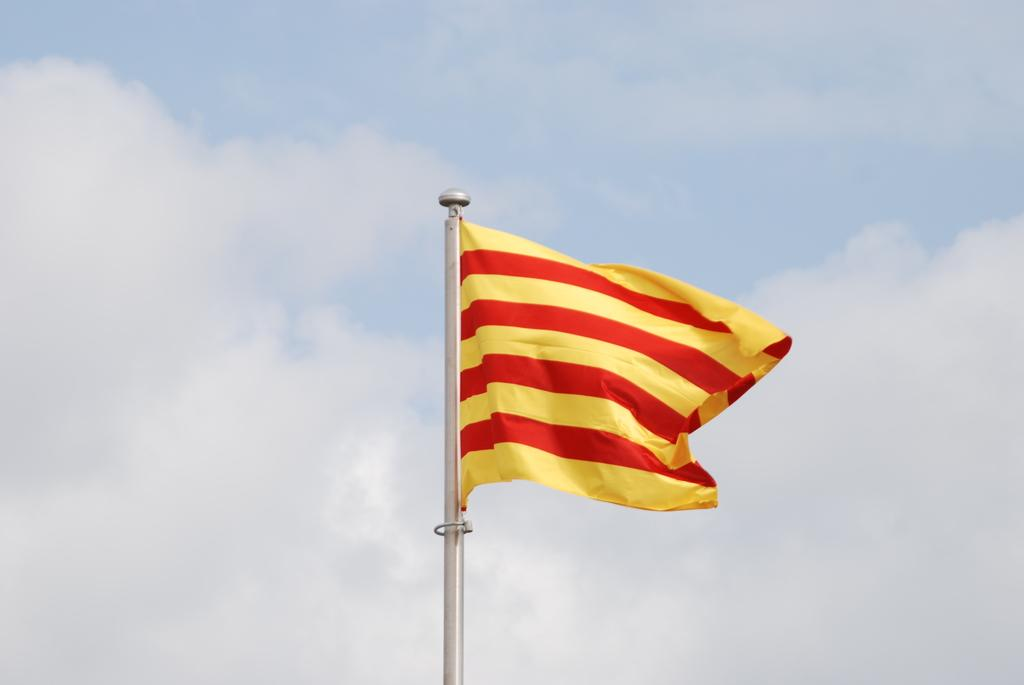What is the main subject in the middle of the image? There is a flag pole in the middle of the image. What can be seen in the background of the image? The sky is visible in the background of the image. Can you determine the time of day the image was taken? The image was likely taken during the day, as the sky is visible and there is no indication of darkness. What type of yak can be seen grazing near the flag pole in the image? There is no yak present in the image; it only features a flag pole and the sky. Can you describe the flame coming from the knee of the person holding the flag pole? There is no person or flame present in the image; it only features a flag pole and the sky. 